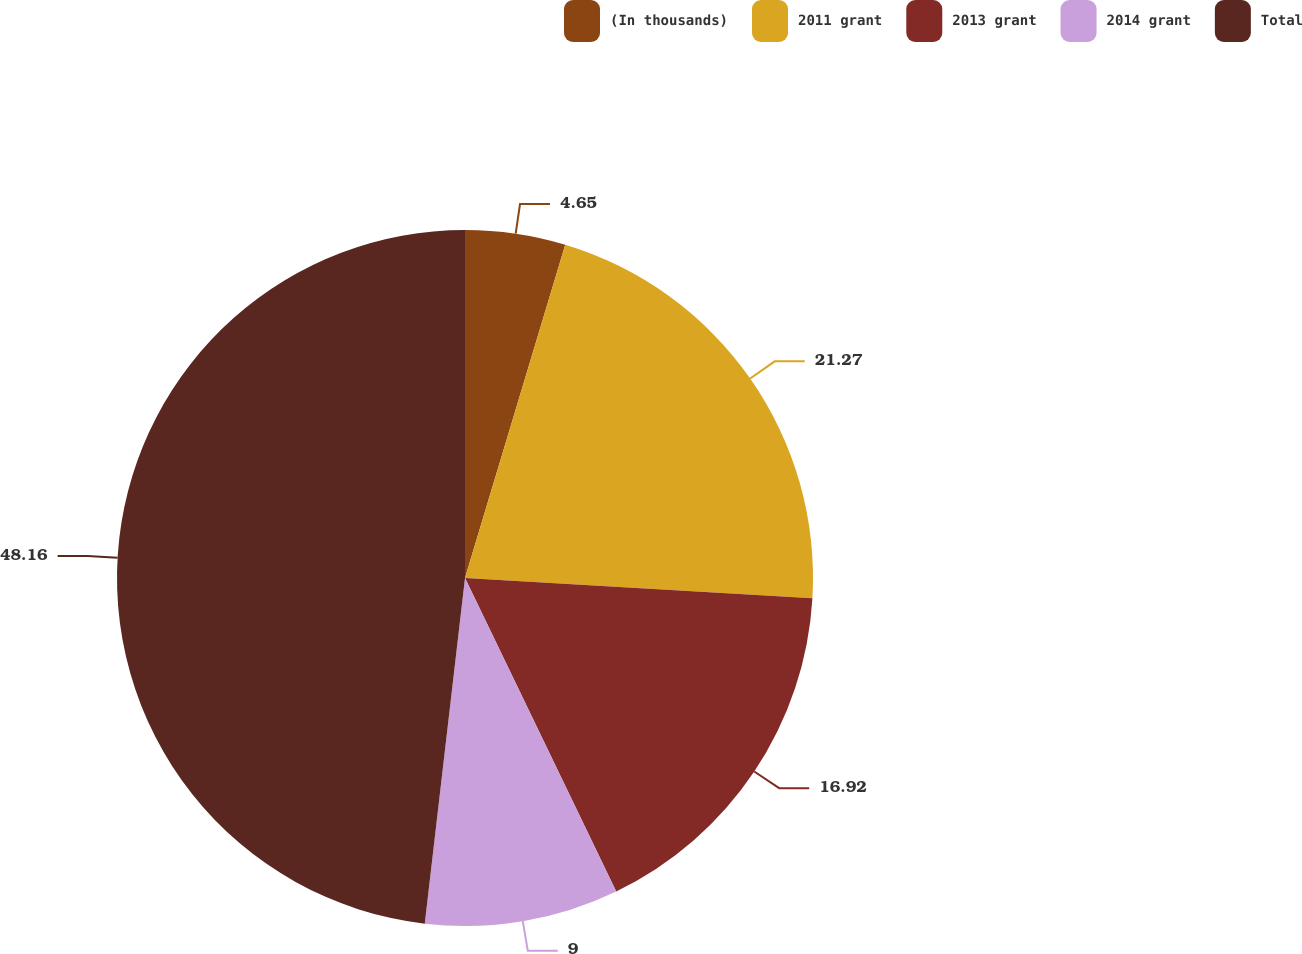Convert chart. <chart><loc_0><loc_0><loc_500><loc_500><pie_chart><fcel>(In thousands)<fcel>2011 grant<fcel>2013 grant<fcel>2014 grant<fcel>Total<nl><fcel>4.65%<fcel>21.27%<fcel>16.92%<fcel>9.0%<fcel>48.15%<nl></chart> 